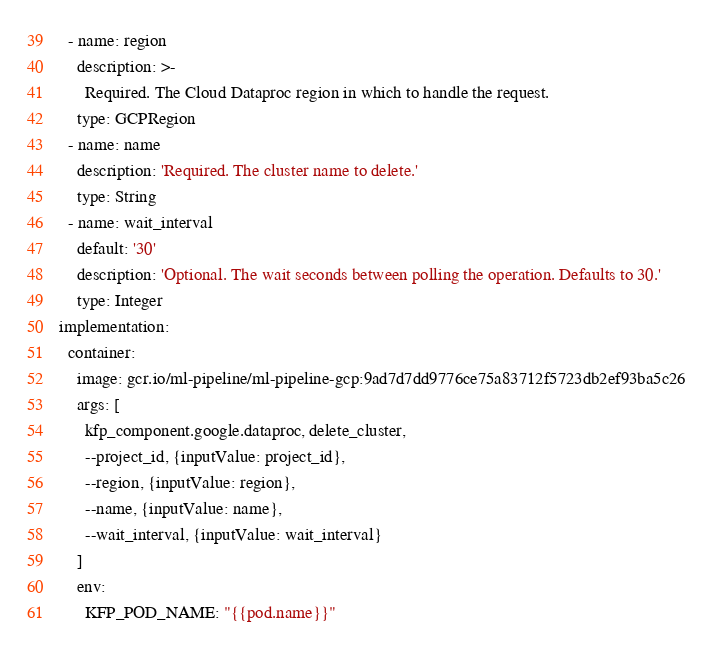Convert code to text. <code><loc_0><loc_0><loc_500><loc_500><_YAML_>  - name: region
    description: >-
      Required. The Cloud Dataproc region in which to handle the request.
    type: GCPRegion
  - name: name
    description: 'Required. The cluster name to delete.'
    type: String
  - name: wait_interval
    default: '30'
    description: 'Optional. The wait seconds between polling the operation. Defaults to 30.'
    type: Integer
implementation:
  container:
    image: gcr.io/ml-pipeline/ml-pipeline-gcp:9ad7d7dd9776ce75a83712f5723db2ef93ba5c26
    args: [
      kfp_component.google.dataproc, delete_cluster,
      --project_id, {inputValue: project_id},
      --region, {inputValue: region},
      --name, {inputValue: name},
      --wait_interval, {inputValue: wait_interval}
    ]
    env:
      KFP_POD_NAME: "{{pod.name}}"</code> 